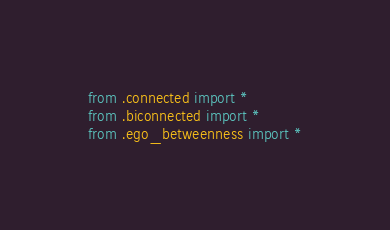Convert code to text. <code><loc_0><loc_0><loc_500><loc_500><_Python_>from .connected import *
from .biconnected import *
from .ego_betweenness import *</code> 